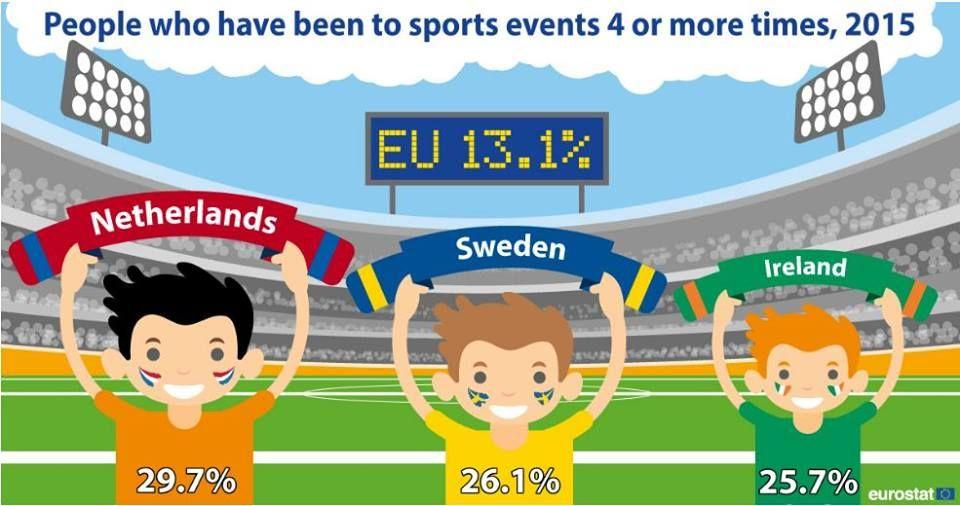Draw attention to some important aspects in this diagram. In 2015, the people of the Netherlands attended the most sports events. The boy is wearing a shirt with a color that is being held by Sweden, and that color is yellow. 